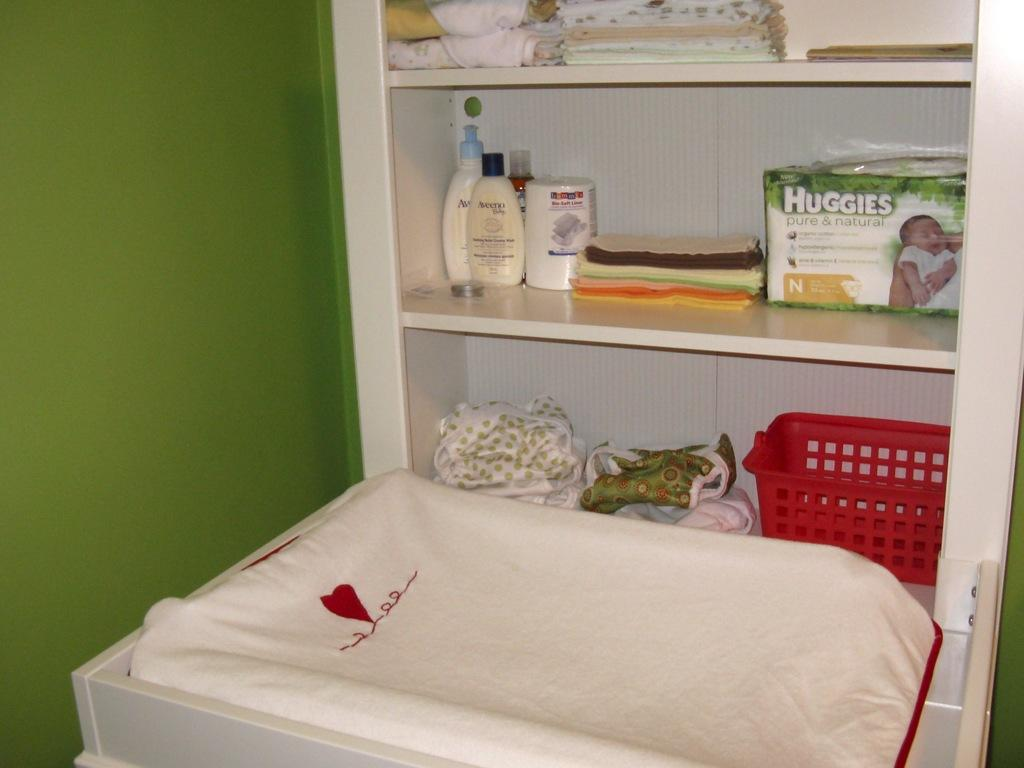<image>
Present a compact description of the photo's key features. Shelves with various items including Huggies diapers are near a changing table. 